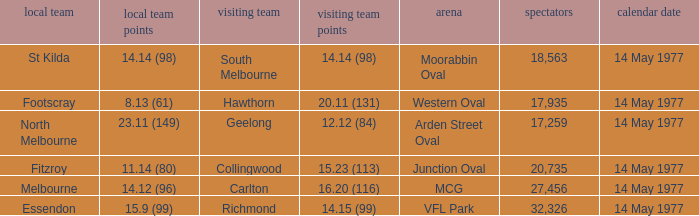Name the away team for essendon Richmond. 